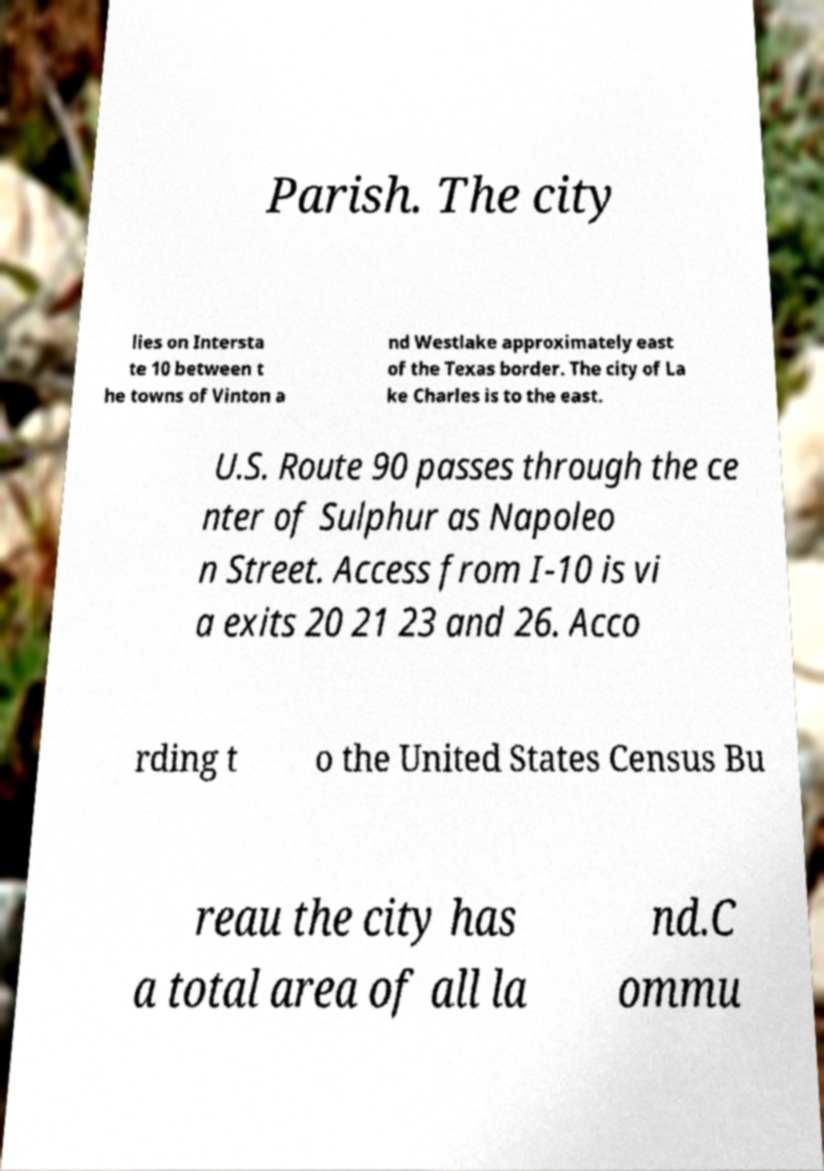Could you extract and type out the text from this image? Parish. The city lies on Intersta te 10 between t he towns of Vinton a nd Westlake approximately east of the Texas border. The city of La ke Charles is to the east. U.S. Route 90 passes through the ce nter of Sulphur as Napoleo n Street. Access from I-10 is vi a exits 20 21 23 and 26. Acco rding t o the United States Census Bu reau the city has a total area of all la nd.C ommu 